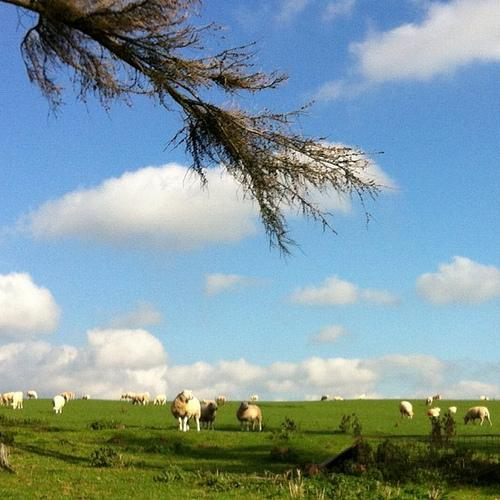Write a short poem about the image. Where sheep and nature both do flourish. Compose a sentence describing the textures and colors of the sheep in this image. The sheep, with their soft white fleece, create a delightful contrast against the bright green grass and blue sky overhead. Describe the atmosphere in the image. The atmosphere in the image is calm and serene, with sheep grazing on lush green grass under a beautiful sky filled with white, fluffy clouds. Write a tagline for a product advertisement featuring the image. Discover tranquility in every step with our soft, comfortable, and sustainably-sourced sheepskin footwear, inspired by nature itself. What is the primary subject of the image? The primary subject of the image is the flock of white sheep grazing in a large green field. Describe the weather conditions in the image. The weather in the image appears to be sunny with scattered white clouds against a bright blue sky. Create a caption for this image for a social media post. Peaceful grazing: A beautiful scene of many white sheep enjoying the sunny day in a large, green field with trees and fluffy clouds. Write a brief description of this image for a nature photographer's portfolio. This captivating photograph features a flock of sheep grazing in a vast, verdant field, framed by trees and a picturesque, cloudy sky—an idyllic portrait of nature's beauty. Mention the main elements of the landscape in this image. The image features a large green field, white sheep grazing, a cloudy sky, trees on the horizon, and small bushes. For a multi-choice VQA task, what is the predominant color of the sheep in the image? The predominant color of the sheep in the image is white. 